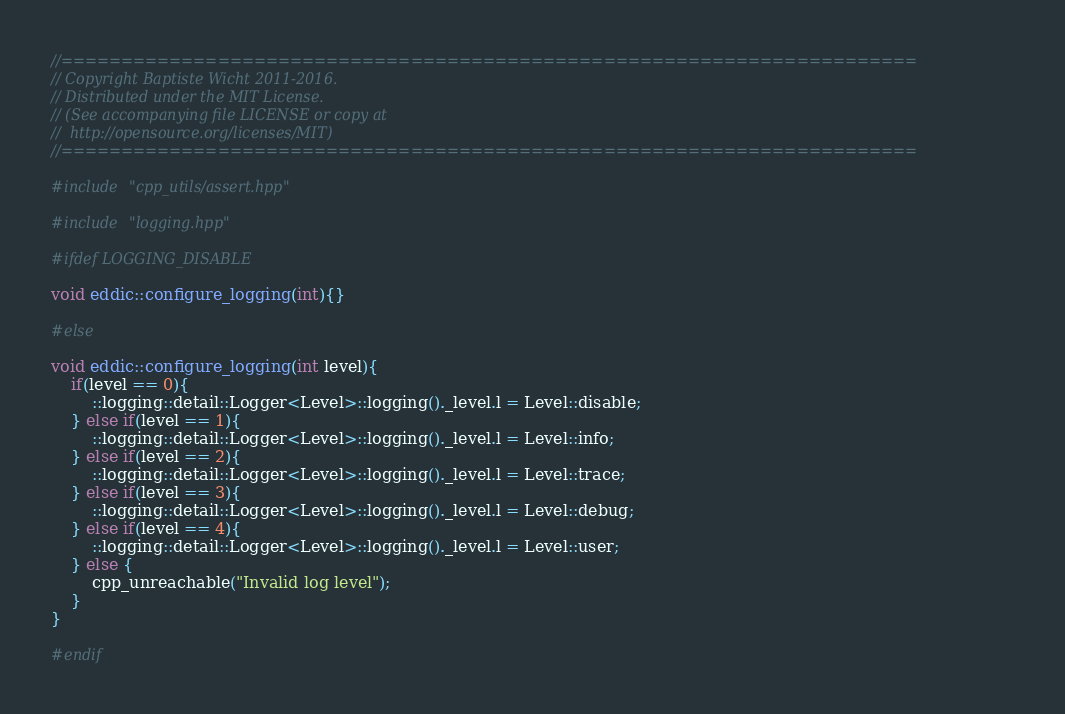Convert code to text. <code><loc_0><loc_0><loc_500><loc_500><_C++_>//=======================================================================
// Copyright Baptiste Wicht 2011-2016.
// Distributed under the MIT License.
// (See accompanying file LICENSE or copy at
//  http://opensource.org/licenses/MIT)
//=======================================================================

#include "cpp_utils/assert.hpp"

#include "logging.hpp"

#ifdef LOGGING_DISABLE

void eddic::configure_logging(int){}

#else

void eddic::configure_logging(int level){
    if(level == 0){
        ::logging::detail::Logger<Level>::logging()._level.l = Level::disable;
    } else if(level == 1){
        ::logging::detail::Logger<Level>::logging()._level.l = Level::info;
    } else if(level == 2){
        ::logging::detail::Logger<Level>::logging()._level.l = Level::trace;
    } else if(level == 3){
        ::logging::detail::Logger<Level>::logging()._level.l = Level::debug;
    } else if(level == 4){
        ::logging::detail::Logger<Level>::logging()._level.l = Level::user;
    } else {
        cpp_unreachable("Invalid log level");
    }
}

#endif
</code> 